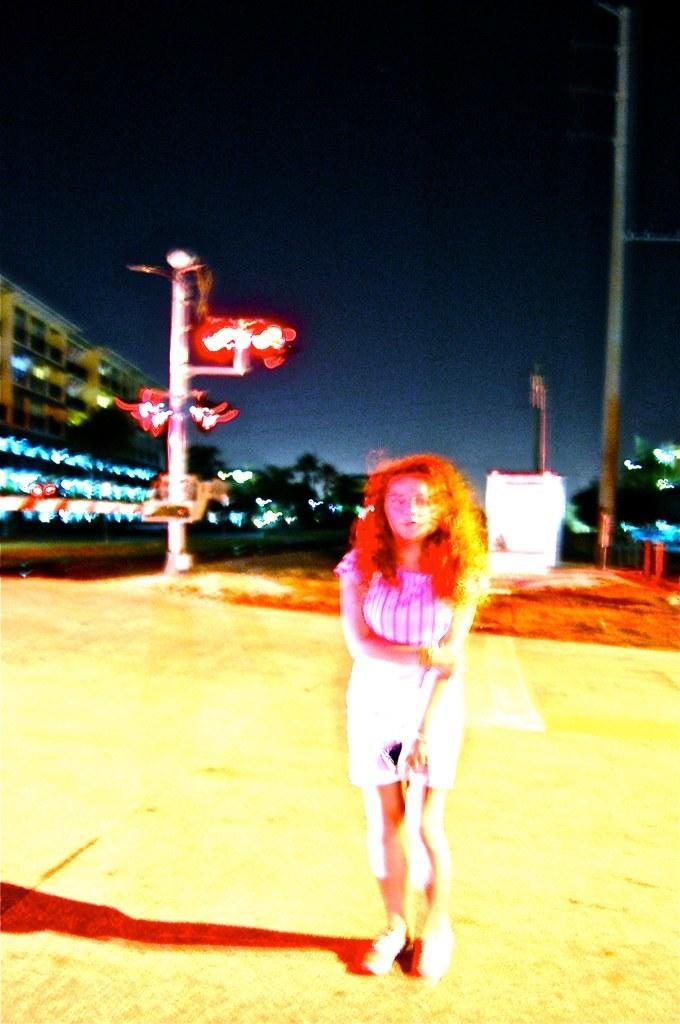Could you give a brief overview of what you see in this image? This picture is clicked outside, it seems to be an edited image. In the foreground there is a person standing on the ground. In the background we can see the sky, poles, buildings and trees and some other objects. 